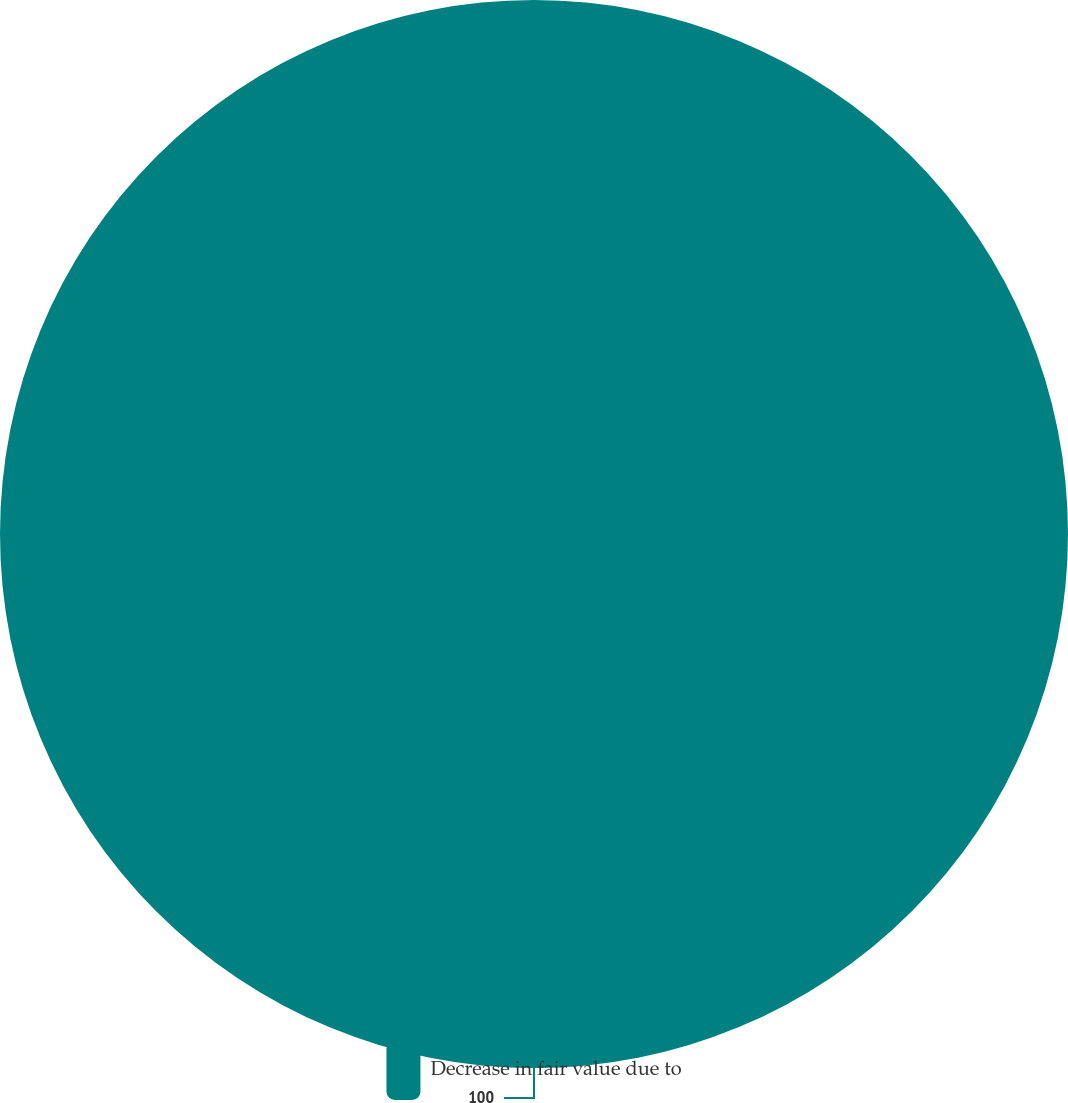<chart> <loc_0><loc_0><loc_500><loc_500><pie_chart><fcel>Decrease in fair value due to<nl><fcel>100.0%<nl></chart> 